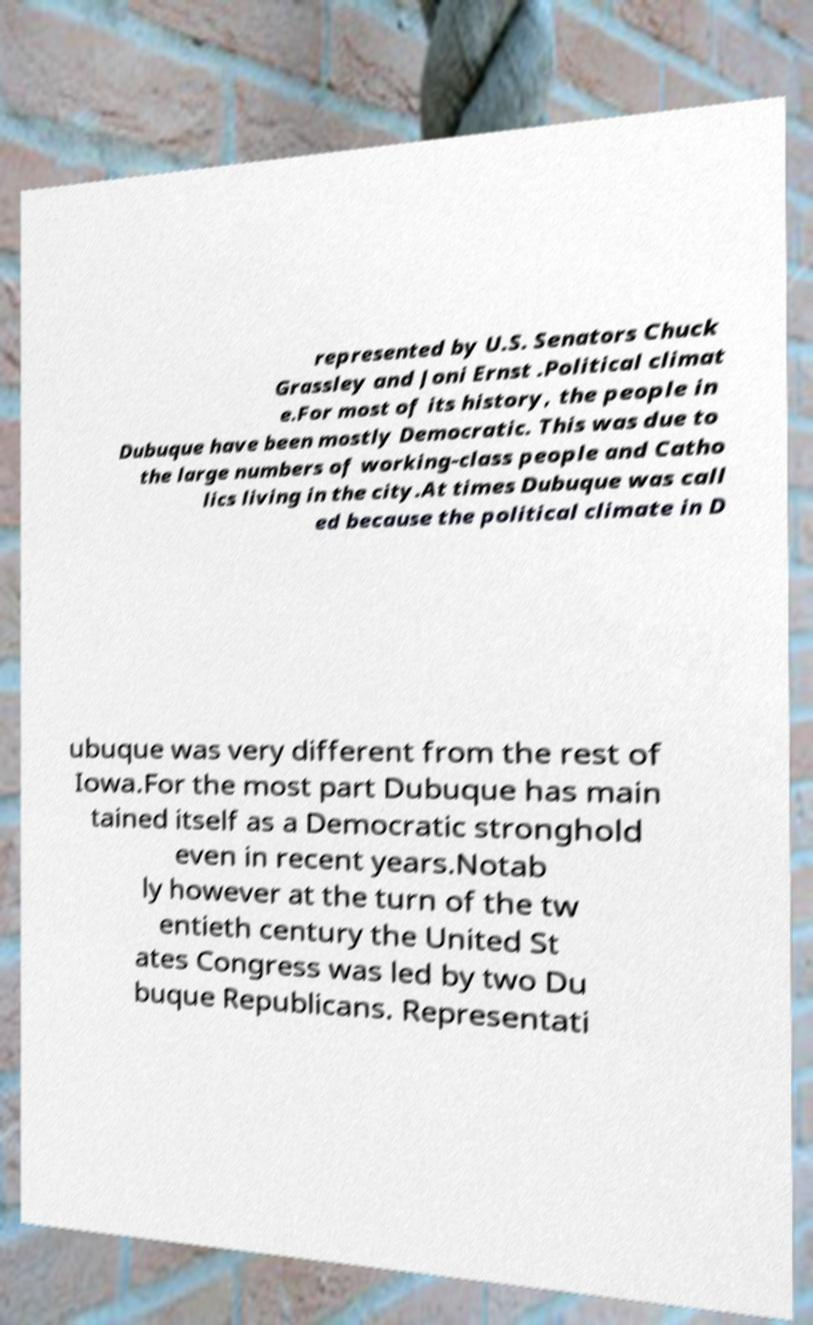I need the written content from this picture converted into text. Can you do that? represented by U.S. Senators Chuck Grassley and Joni Ernst .Political climat e.For most of its history, the people in Dubuque have been mostly Democratic. This was due to the large numbers of working-class people and Catho lics living in the city.At times Dubuque was call ed because the political climate in D ubuque was very different from the rest of Iowa.For the most part Dubuque has main tained itself as a Democratic stronghold even in recent years.Notab ly however at the turn of the tw entieth century the United St ates Congress was led by two Du buque Republicans. Representati 